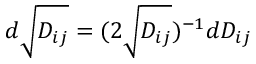Convert formula to latex. <formula><loc_0><loc_0><loc_500><loc_500>d \sqrt { D _ { i j } } = ( 2 \sqrt { D _ { i j } } ) ^ { - 1 } d D _ { i j }</formula> 